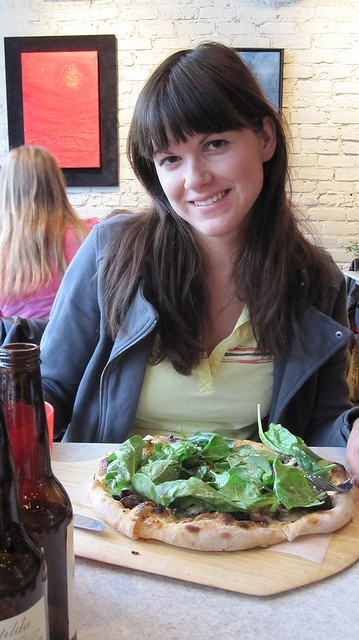Describe the objects in this image and their specific colors. I can see people in lightgray, black, gray, darkgray, and brown tones, pizza in lightgray, darkgray, green, darkgreen, and gray tones, dining table in lightgray, lavender, darkgray, and gray tones, bottle in lightgray, black, maroon, darkgray, and gray tones, and people in lightgray, darkgray, brown, and lightpink tones in this image. 